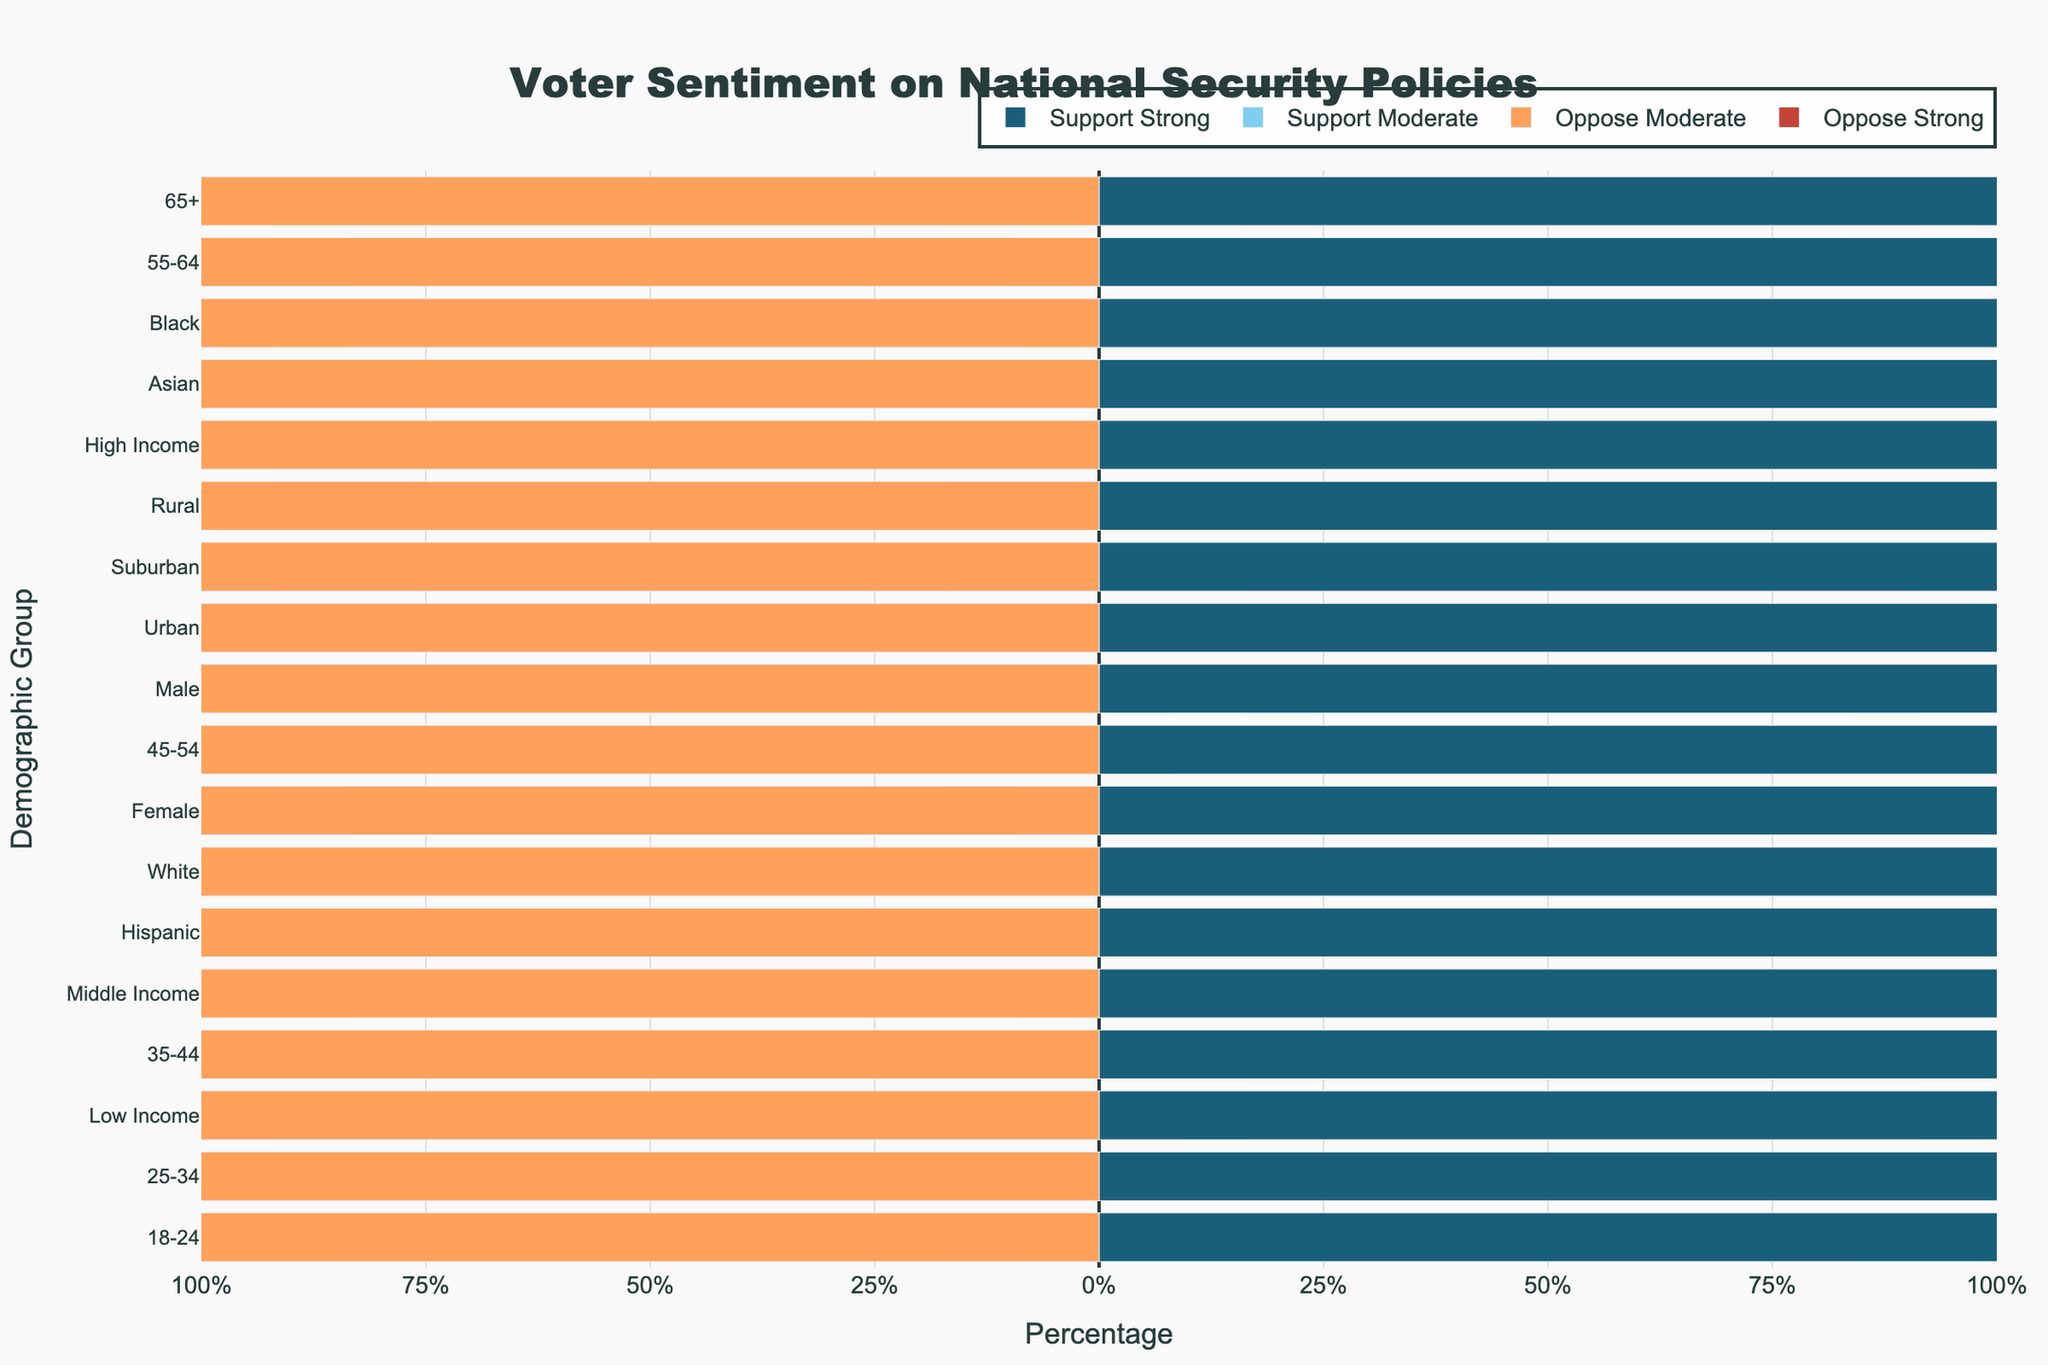Which demographic group shows the highest percentage of support for strong security? To identify this, check the bar color associated with "Support Strong" across all demographic groups. The longest bar in the darkest color (indicating "Support Strong") is for the "65+" demographic group.
Answer: 65+ Which demographic group shows the least opposition to strong security policies? To find this, look for the shortest bar colored in the darkest shade of opposition ("Oppose Strong"). The shortest bar is for the "65+" demographic group with a value of 8%.
Answer: 65+ What is the total percentage of people aged 45-54 years supporting security policies (both strong and moderate support)? Add the percentages of "Support Strong Security" and "Support Moderate Security" for the 45-54 age group. This is 30% (Support Strong) + 40% (Support Moderate) = 70%.
Answer: 70% Compare the support for strong security policies between males and females. Which group shows more support? Compare the lengths of the bars colored for "Support Strong" for Males and Females. Males show 35% while Females show 25%. Thus, Males show more support.
Answer: Male Which income category shows the highest overall opposition to security policies (both strong and moderate)? Calculate the sum of opposition (both strong and moderate) for all income categories. Low Income: 30% + 20% = 50%, Middle Income: 25% + 15% = 40%, High Income: 20% + 10% = 30%. Therefore, Low Income shows the highest opposition.
Answer: Low Income What is the difference in total opposition (both strong and moderate) between Black and Hispanic demographics? Calculate the total opposition for both groups: Black: 22% (Strong) + 5% (Moderate) = 27%, Hispanic: 28% (Strong) + 10% (Moderate) = 38%. Difference: 38% - 27% = 11%.
Answer: 11% Which demographic group has the most balanced opinion towards security policies, defined by the least difference between total support and total opposition percentages? Calculate the total support and total opposition percentages for each group and find the difference. The Closest values are found for the "Urban" demographic: Support: 30% + 40% = 70%, Opposition: 20% + 10% = 30%, Difference: 70% - 30% = 40%. Check other groups similarly to confirm.
Answer: Urban Is there a demographic group where opposition to security policies (both strong and moderate) is greater than support? Check each group; support must be lower than opposition. The Low Income demographic shows support: 20% + 30% = 50%, opposition: 30% + 20% = 50%. No clear majority opposition over support; scan all such categories.
Answer: None Which age group has the largest proportion supporting moderate security policies? Compare the lengths of the bars for "Support Moderate Security" for each age group. The 65+ age group has 50%, which is higher than all other age groups.
Answer: 65+ How does the opposition of strong security policies for Asians compare to that of Whites and Hispanics? Verify the bars colored for "Oppose Strong Security": Asians: 20%, Whites: 27%, Hispanics: 28%. Asians have the lowest percentage of opposition to strong security policies among the three.
Answer: Lowest 